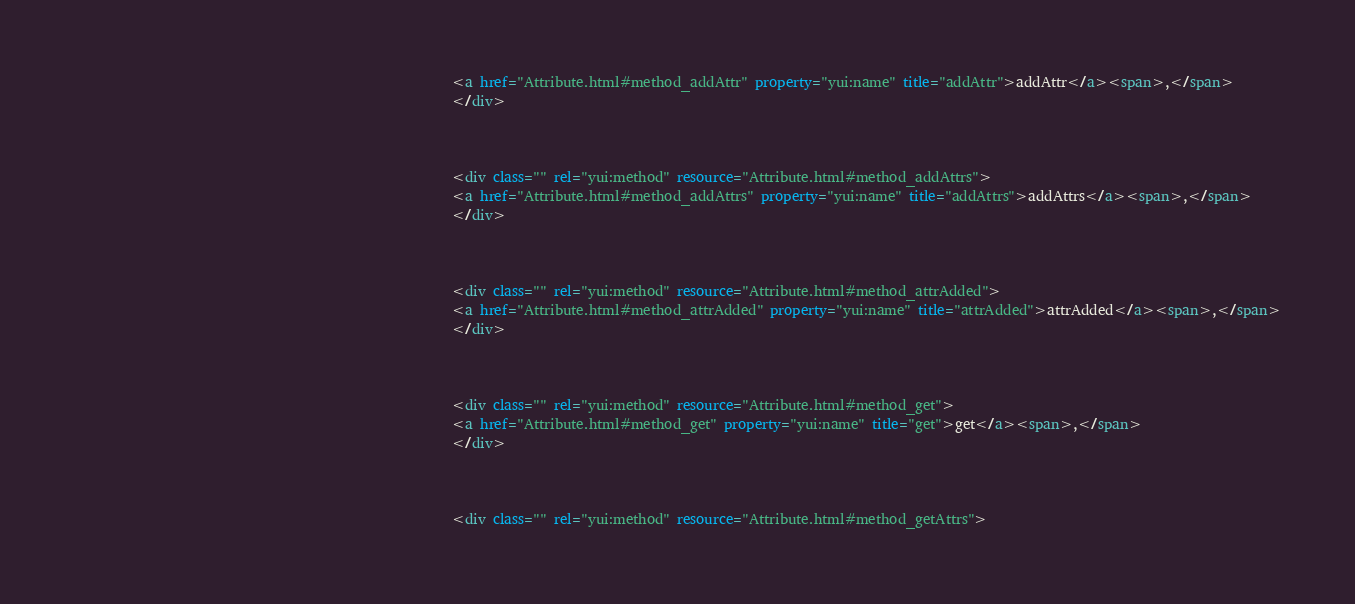Convert code to text. <code><loc_0><loc_0><loc_500><loc_500><_HTML_>														<a href="Attribute.html#method_addAttr" property="yui:name" title="addAttr">addAttr</a><span>,</span>
														</div>

														

														<div class="" rel="yui:method" resource="Attribute.html#method_addAttrs">
														<a href="Attribute.html#method_addAttrs" property="yui:name" title="addAttrs">addAttrs</a><span>,</span>
														</div>

														

														<div class="" rel="yui:method" resource="Attribute.html#method_attrAdded">
														<a href="Attribute.html#method_attrAdded" property="yui:name" title="attrAdded">attrAdded</a><span>,</span>
														</div>

														

														<div class="" rel="yui:method" resource="Attribute.html#method_get">
														<a href="Attribute.html#method_get" property="yui:name" title="get">get</a><span>,</span>
														</div>

														

														<div class="" rel="yui:method" resource="Attribute.html#method_getAttrs"></code> 